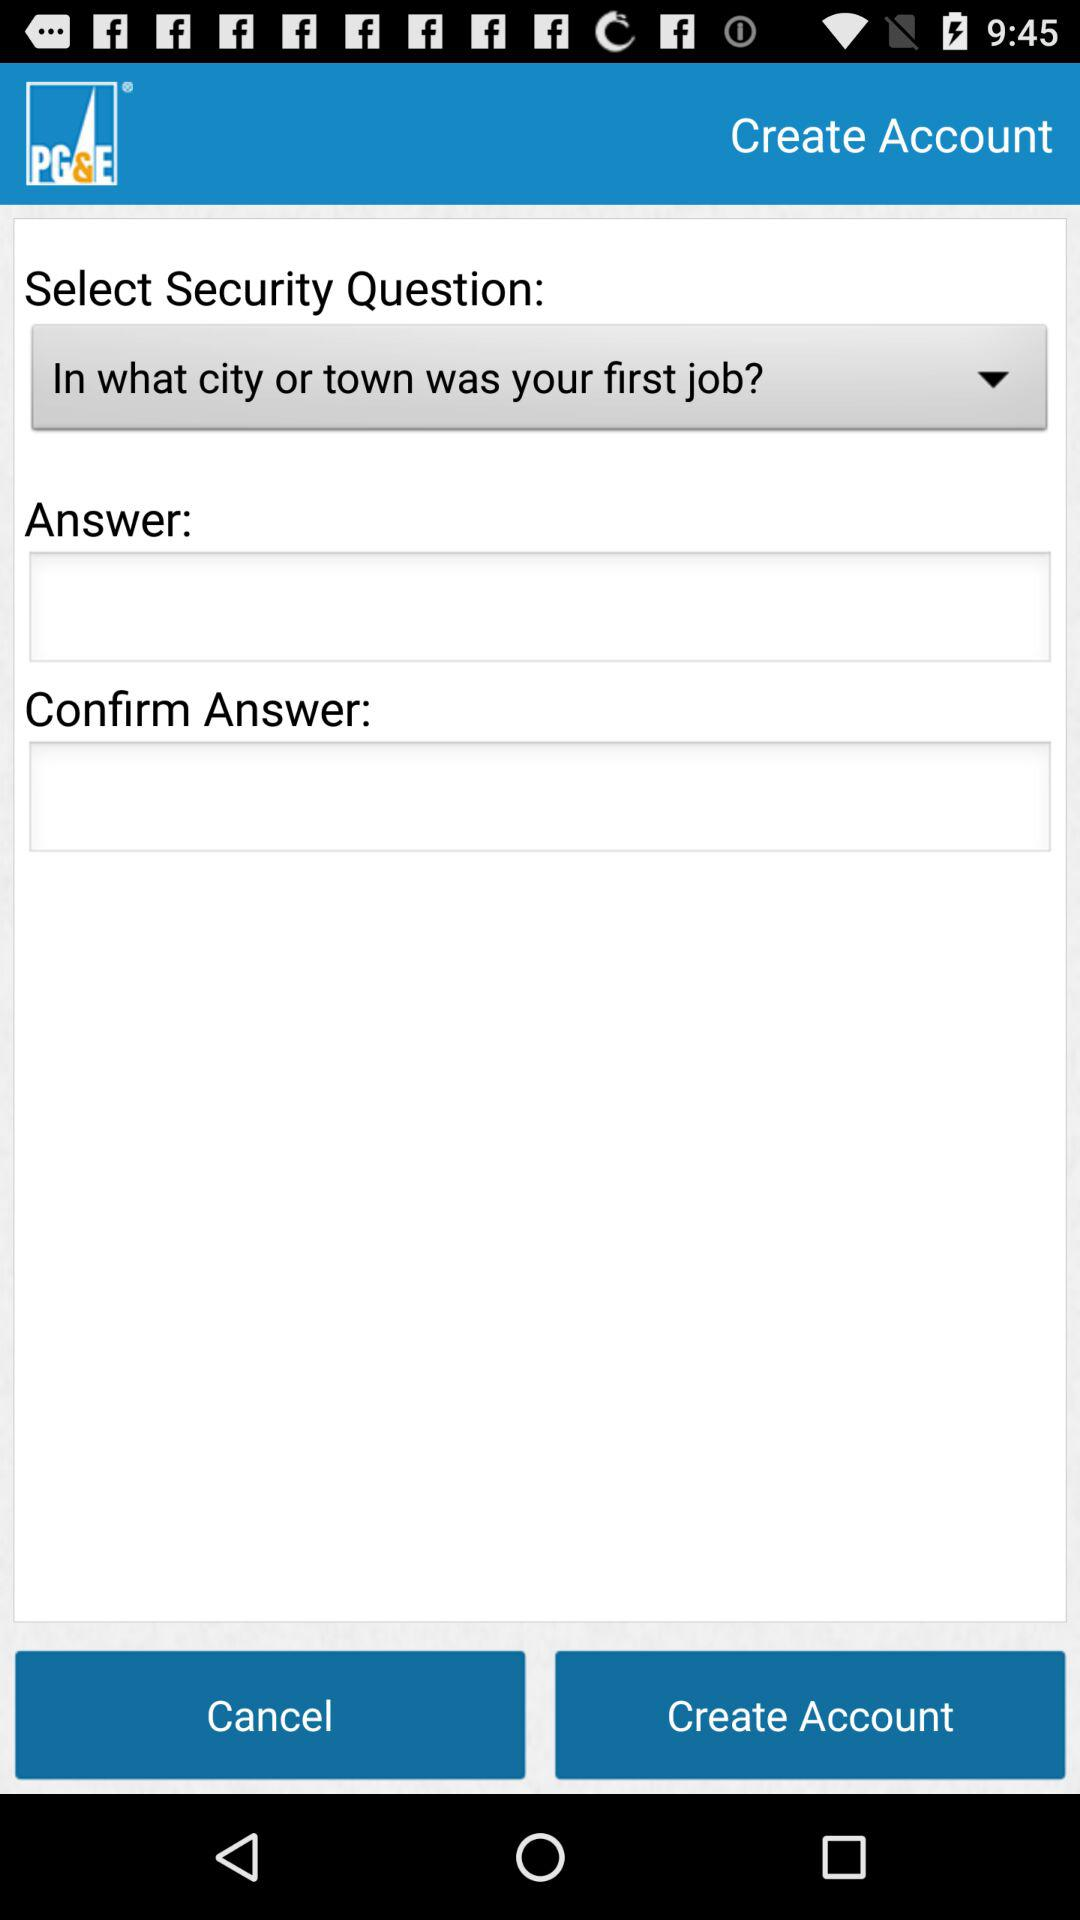What is the application name? The application name is "PG&E Mobile Bill Pay". 